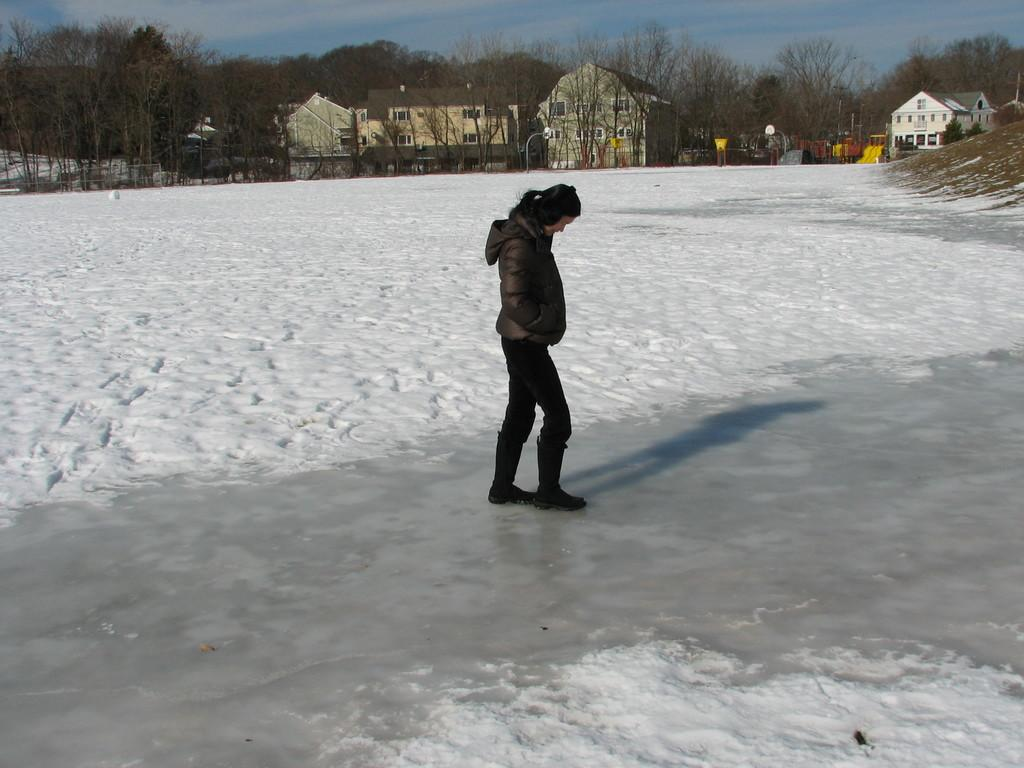Who is the main subject in the image? There is a woman standing in the center of the image. What is the surface the woman is standing on? The woman is standing on snow. What can be seen in the background of the image? There are buildings, trees, vehicles, and the sky visible in the background of the image. What is the condition of the sky in the image? The sky is visible in the background of the image, and there are clouds present. What is the name of the giant standing next to the woman in the image? There are no giants present in the image; it features a woman standing on snow with various background elements. What day of the week is depicted in the image? The image does not depict a specific day of the week; it is a still photograph. 